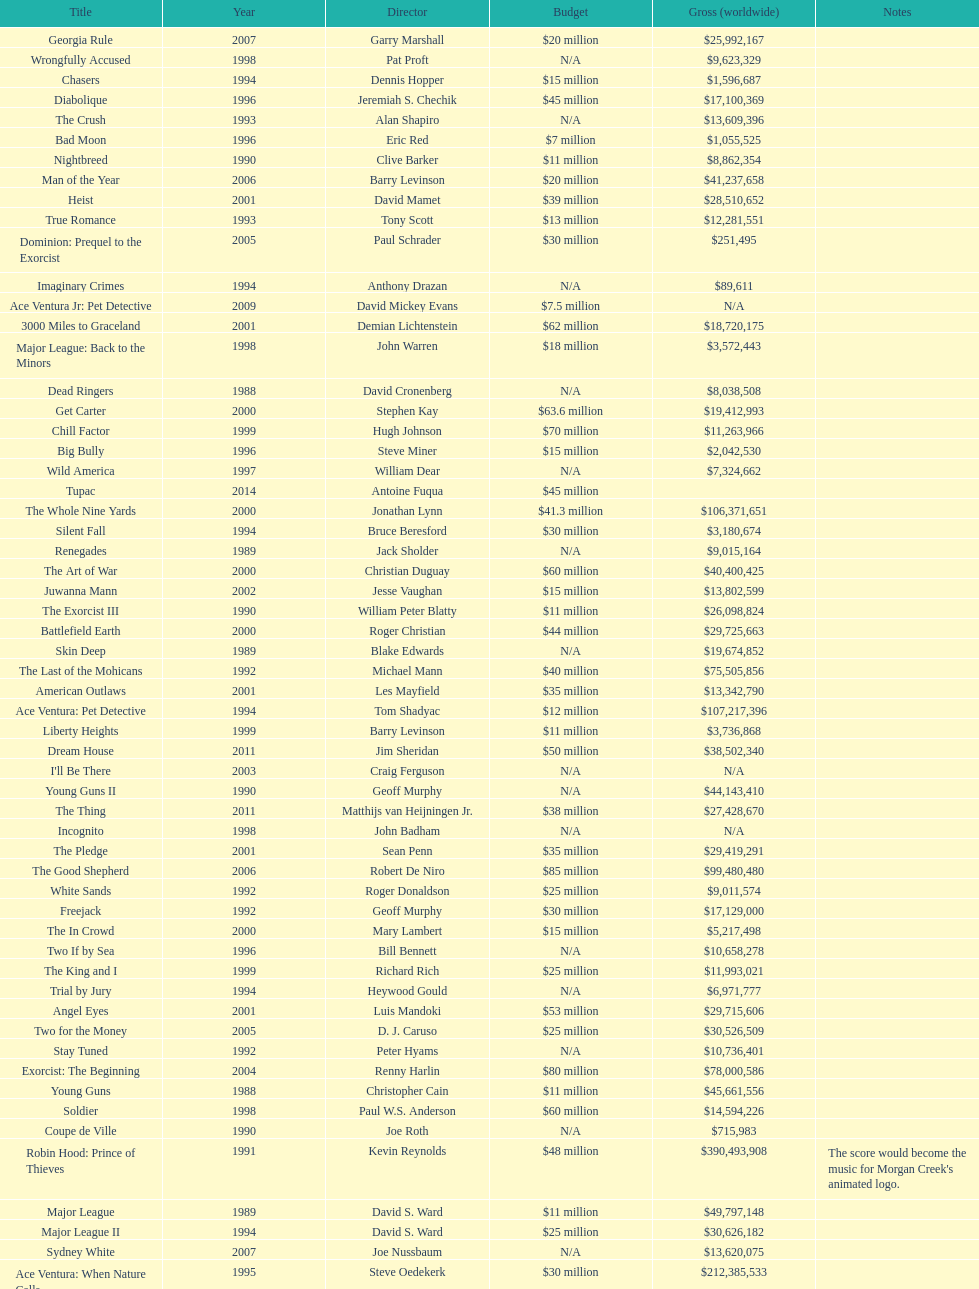Was the budget for young guns more or less than freejack's budget? Less. 